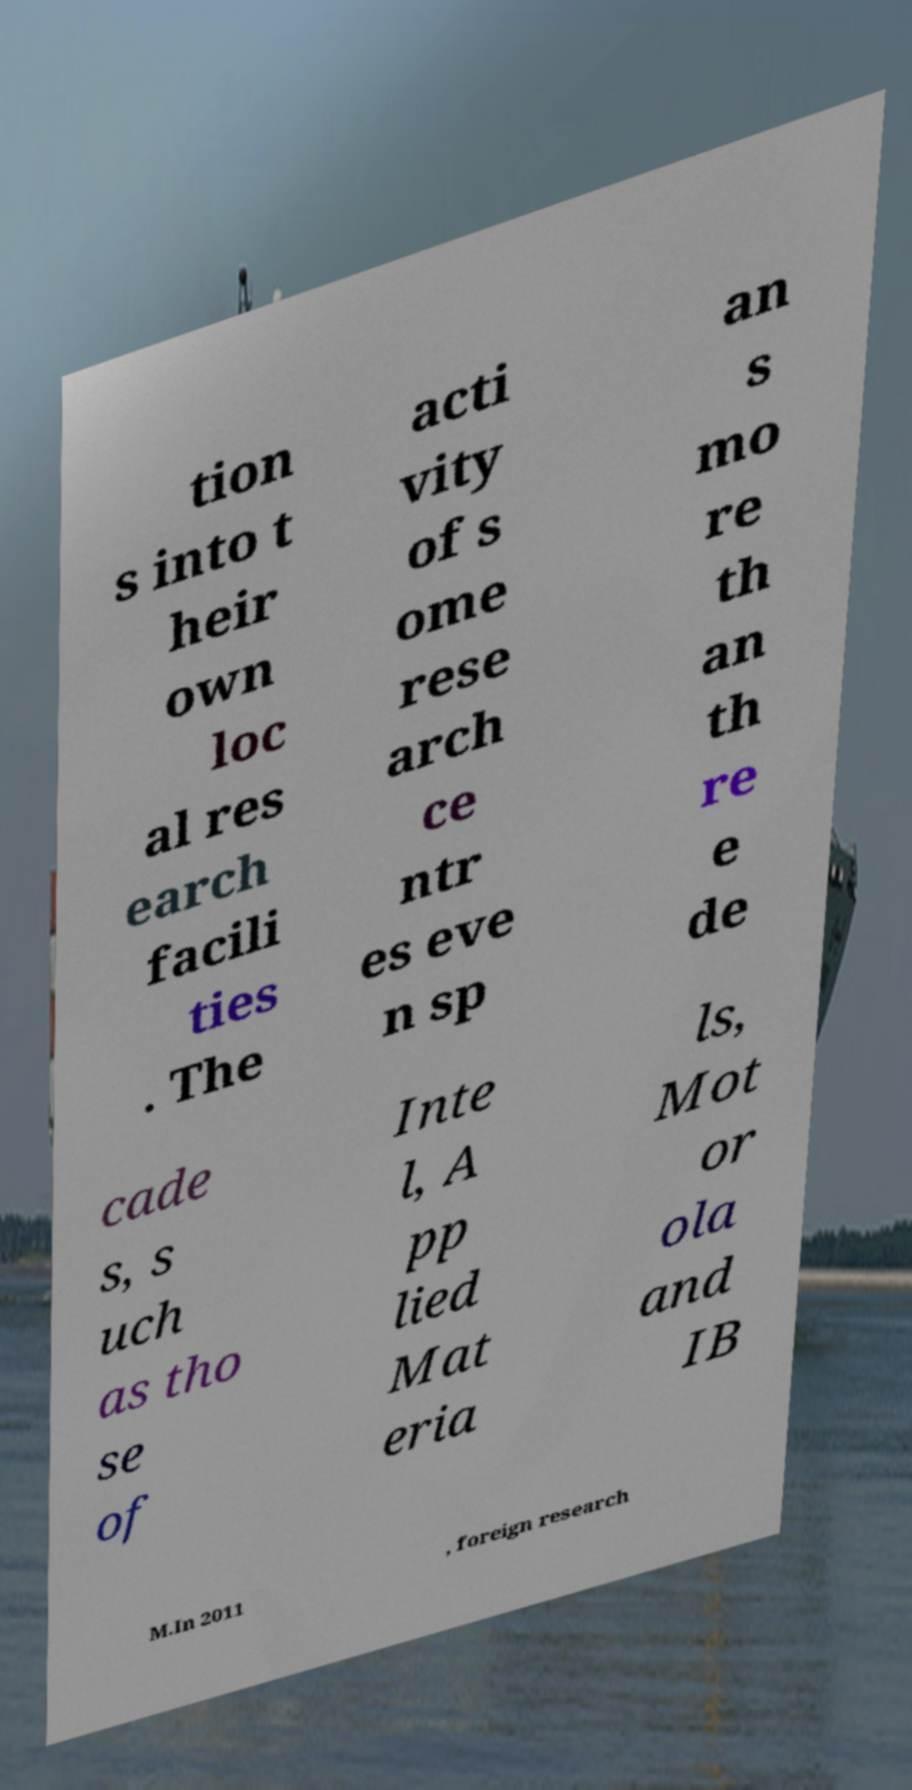Please identify and transcribe the text found in this image. tion s into t heir own loc al res earch facili ties . The acti vity of s ome rese arch ce ntr es eve n sp an s mo re th an th re e de cade s, s uch as tho se of Inte l, A pp lied Mat eria ls, Mot or ola and IB M.In 2011 , foreign research 